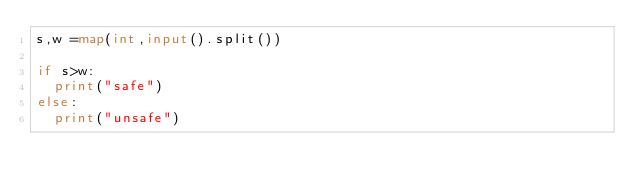<code> <loc_0><loc_0><loc_500><loc_500><_Python_>s,w =map(int,input().split())
 
if s>w:
  print("safe")
else:
  print("unsafe")</code> 